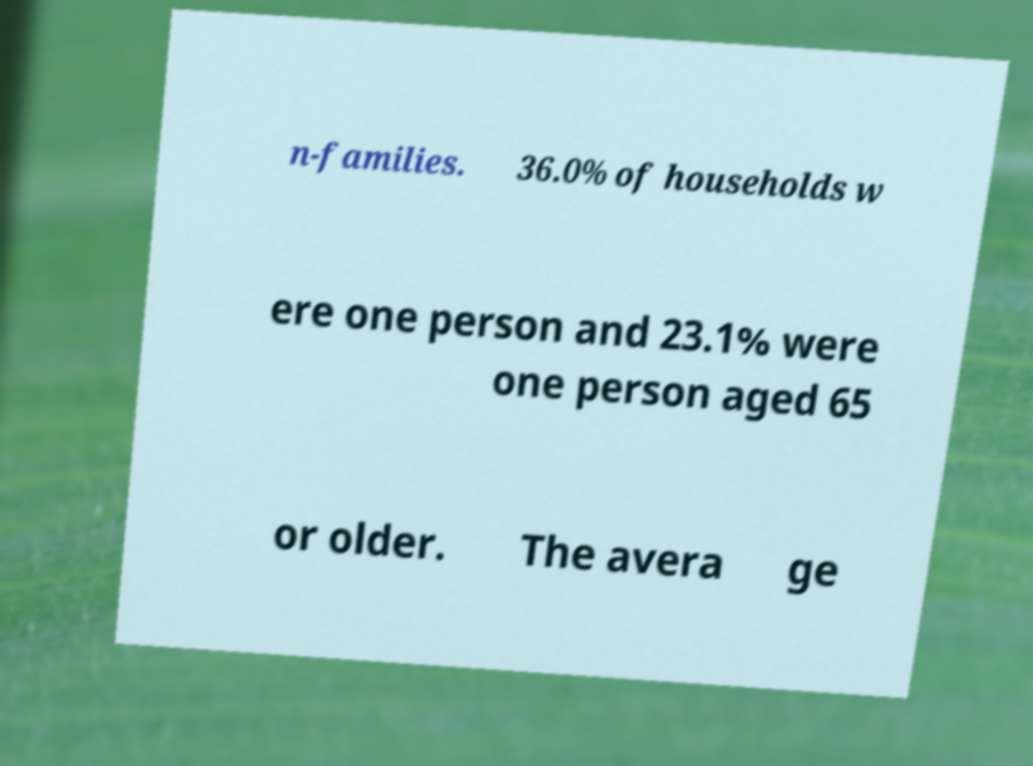What messages or text are displayed in this image? I need them in a readable, typed format. n-families. 36.0% of households w ere one person and 23.1% were one person aged 65 or older. The avera ge 